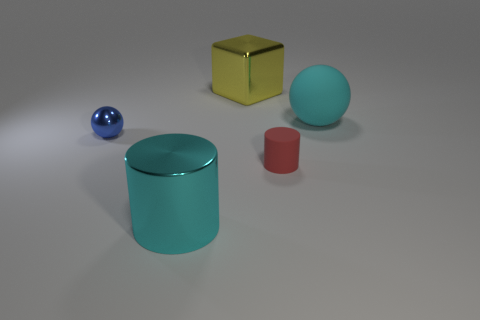The large cyan object in front of the matte thing that is behind the tiny cylinder is what shape?
Offer a terse response. Cylinder. Is the number of tiny red metal balls less than the number of small blue balls?
Your answer should be very brief. Yes. The metallic object in front of the tiny blue ball is what color?
Offer a terse response. Cyan. What material is the object that is to the right of the cyan cylinder and in front of the large sphere?
Offer a very short reply. Rubber. There is a yellow object that is made of the same material as the small blue object; what is its shape?
Keep it short and to the point. Cube. There is a ball that is right of the tiny blue shiny ball; what number of big shiny things are on the right side of it?
Keep it short and to the point. 0. What number of tiny objects are both in front of the blue thing and to the left of the large cube?
Give a very brief answer. 0. What number of other objects are the same material as the big cyan ball?
Provide a succinct answer. 1. There is a large shiny object that is right of the cylinder to the left of the big yellow metal thing; what color is it?
Make the answer very short. Yellow. Is the color of the cylinder that is on the left side of the big metallic block the same as the large rubber sphere?
Keep it short and to the point. Yes. 